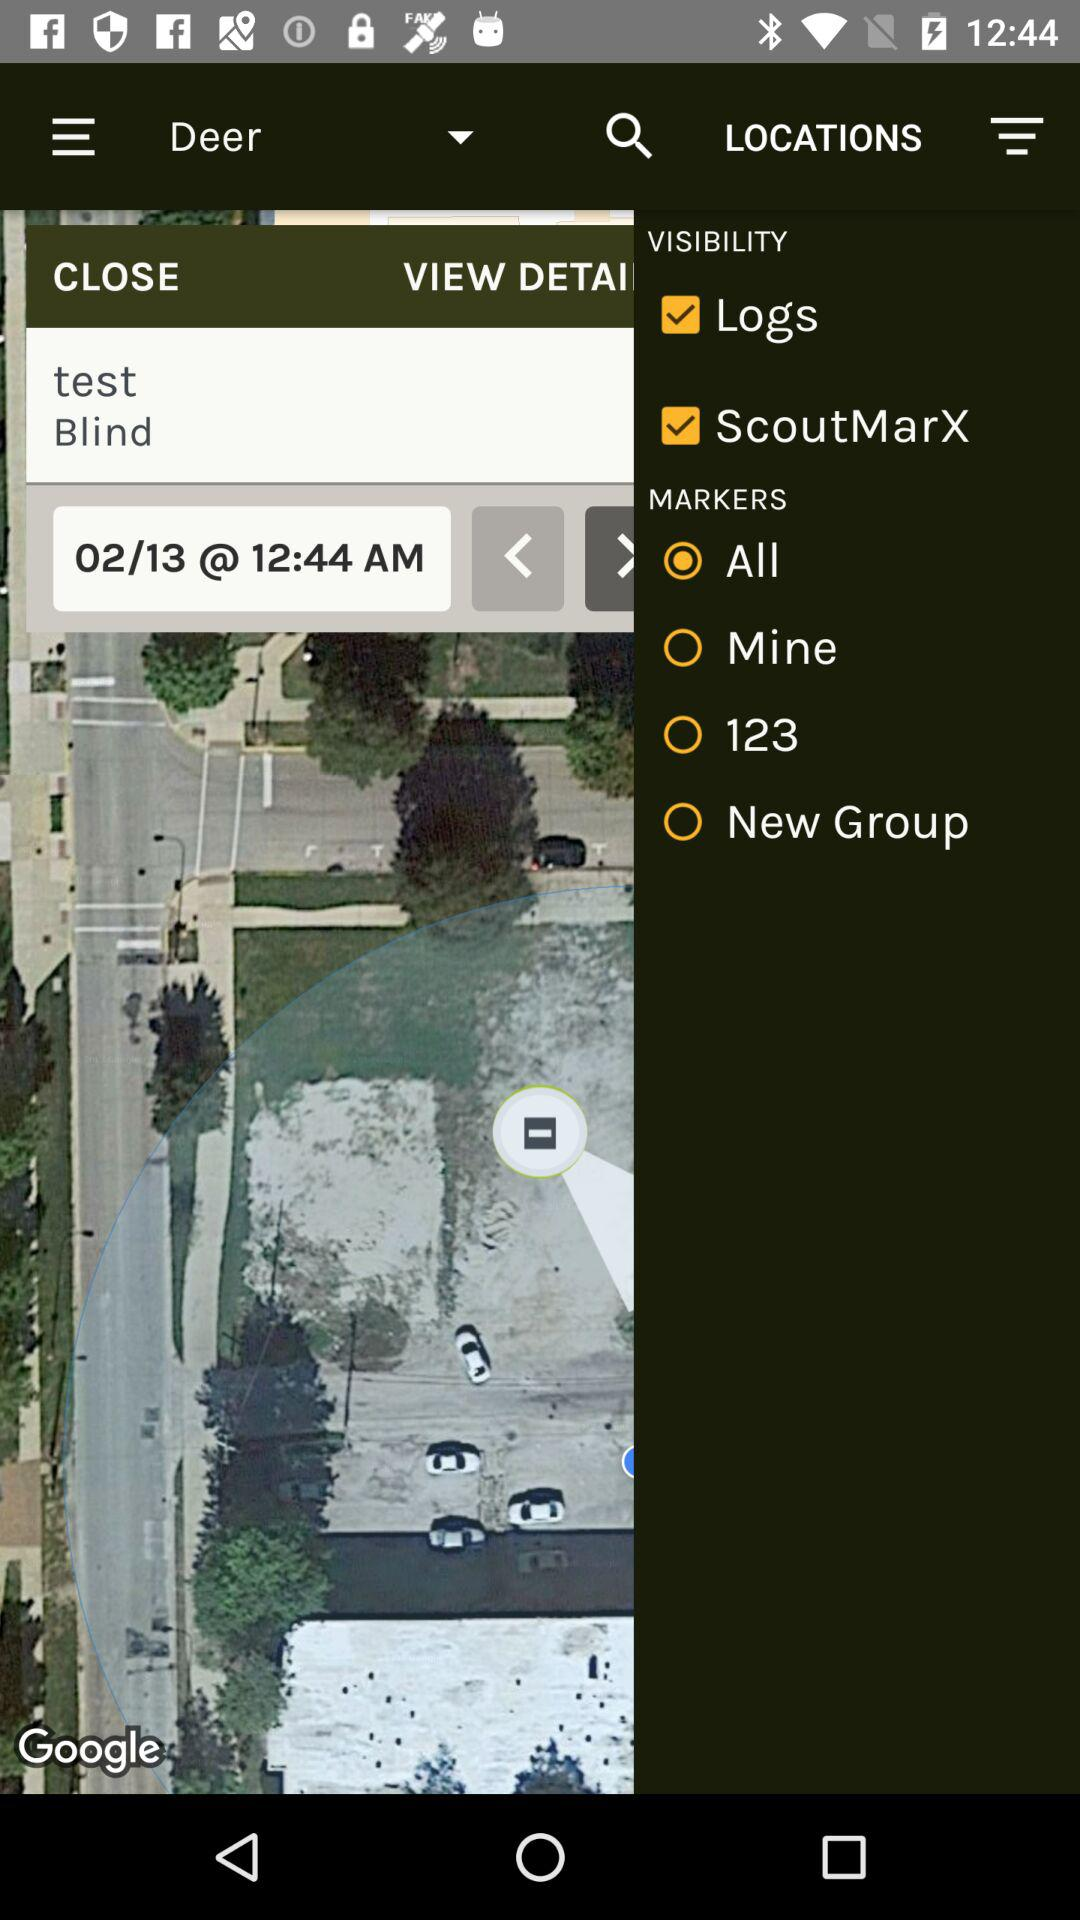What is the current status of "Logs"? The current status of "Logs" is "on". 